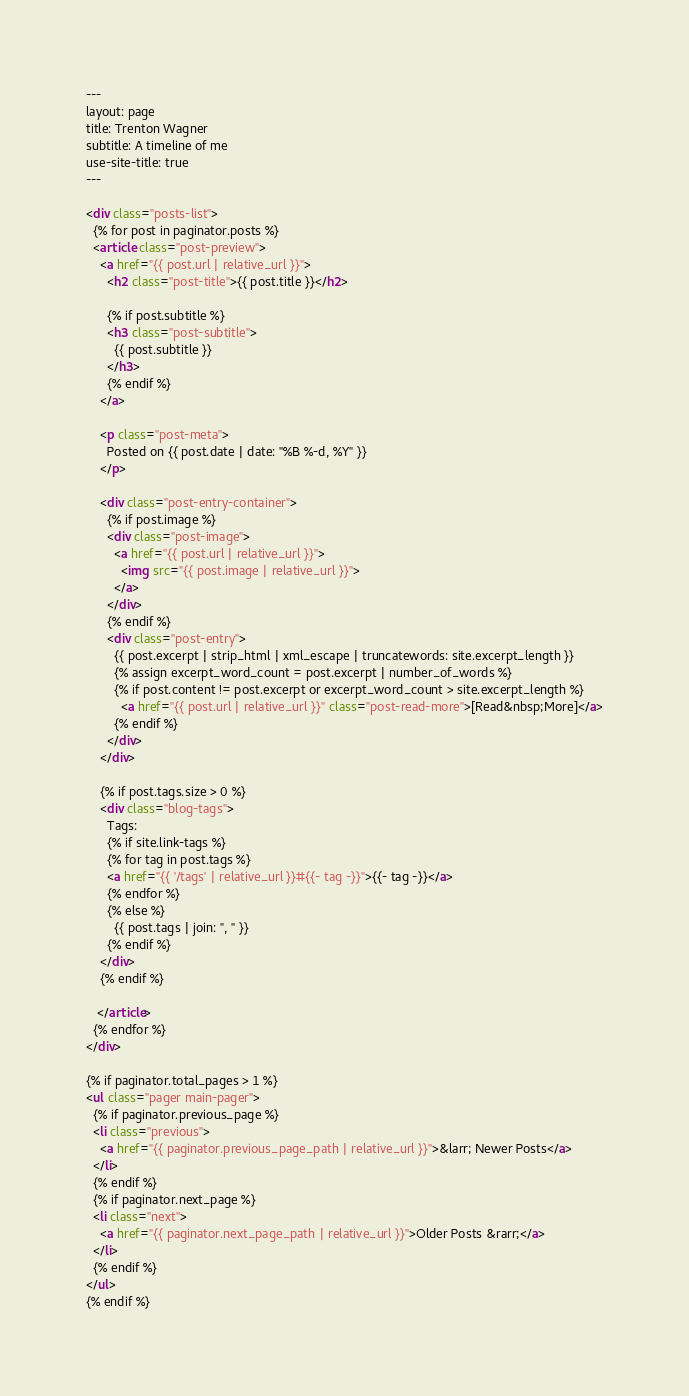Convert code to text. <code><loc_0><loc_0><loc_500><loc_500><_HTML_>---
layout: page
title: Trenton Wagner
subtitle: A timeline of me
use-site-title: true
---

<div class="posts-list">
  {% for post in paginator.posts %}
  <article class="post-preview">
    <a href="{{ post.url | relative_url }}">
	  <h2 class="post-title">{{ post.title }}</h2>

	  {% if post.subtitle %}
	  <h3 class="post-subtitle">
	    {{ post.subtitle }}
	  </h3>
	  {% endif %}
    </a>

    <p class="post-meta">
      Posted on {{ post.date | date: "%B %-d, %Y" }}
    </p>

    <div class="post-entry-container">
      {% if post.image %}
      <div class="post-image">
        <a href="{{ post.url | relative_url }}">
          <img src="{{ post.image | relative_url }}">
        </a>
      </div>
      {% endif %}
      <div class="post-entry">
        {{ post.excerpt | strip_html | xml_escape | truncatewords: site.excerpt_length }}
        {% assign excerpt_word_count = post.excerpt | number_of_words %}
        {% if post.content != post.excerpt or excerpt_word_count > site.excerpt_length %}
          <a href="{{ post.url | relative_url }}" class="post-read-more">[Read&nbsp;More]</a>
        {% endif %}
      </div>
    </div>

    {% if post.tags.size > 0 %}
    <div class="blog-tags">
      Tags:
      {% if site.link-tags %}
      {% for tag in post.tags %}
      <a href="{{ '/tags' | relative_url }}#{{- tag -}}">{{- tag -}}</a>
      {% endfor %}
      {% else %}
        {{ post.tags | join: ", " }}
      {% endif %}
    </div>
    {% endif %}

   </article>
  {% endfor %}
</div>

{% if paginator.total_pages > 1 %}
<ul class="pager main-pager">
  {% if paginator.previous_page %}
  <li class="previous">
    <a href="{{ paginator.previous_page_path | relative_url }}">&larr; Newer Posts</a>
  </li>
  {% endif %}
  {% if paginator.next_page %}
  <li class="next">
    <a href="{{ paginator.next_page_path | relative_url }}">Older Posts &rarr;</a>
  </li>
  {% endif %}
</ul>
{% endif %}
</code> 